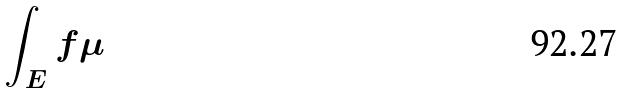<formula> <loc_0><loc_0><loc_500><loc_500>\int _ { E } f \mu</formula> 